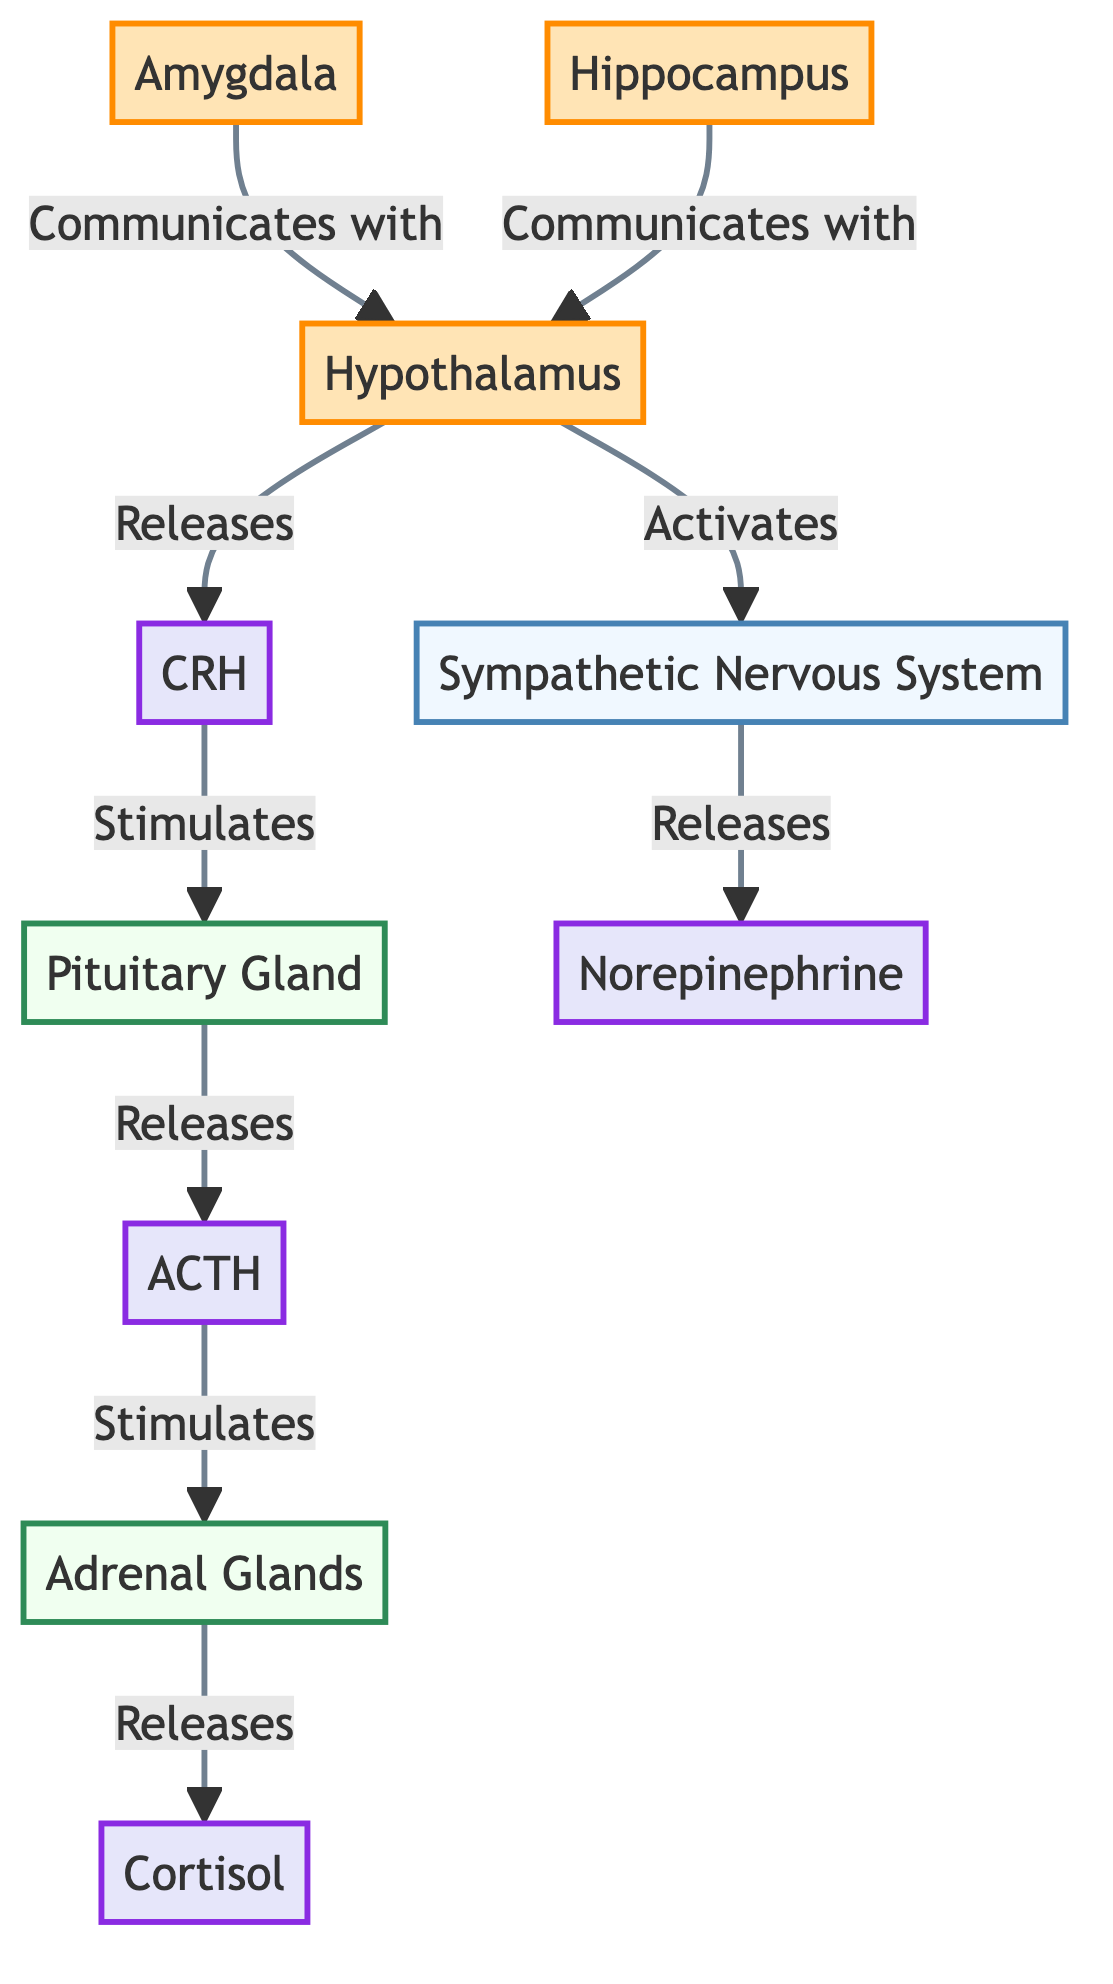What is the first gland activated in the stress response? The diagram shows that the hypothalamus releases CRH. This stimulates the pituitary gland, which then releases ACTH. However, the first gland directly involved in the stress response is the pituitary gland that is activated after the hypothalamus.
Answer: Pituitary Gland How many hormones are listed in the diagram? The diagram features four hormones: CRH, ACTH, cortisol, and norepinephrine. Counting them reveals a total of four distinct hormones.
Answer: 4 Which part of the brain communicates with the hypothalamus besides the amygdala? The diagram indicates that both the amygdala and hippocampus communicate with the hypothalamus. Therefore, answering the question involves identifying the other part mentioned, which is the hippocampus.
Answer: Hippocampus What does the sympathetic nervous system release? According to the diagram, the sympathetic nervous system is shown to release norepinephrine. This follows from the activation process that begins at the hypothalamus and progresses to the sympathetic nervous system's action.
Answer: Norepinephrine Which hormone is released by the adrenal glands? The diagram illustrates the pathway clearly, indicating that once the adrenal glands are stimulated by ACTH, they release cortisol. Therefore, the answer directly corresponds to the hormone listed in that step.
Answer: Cortisol How do CRH and ACTH interact in the stress response? The diagram reflects a sequential flow where CRH stimulates the pituitary gland which then releases ACTH. This establishes a direct relationship of causation where CRH leads to the release of ACTH from the pituitary gland.
Answer: CRH stimulates ACTH release What role does the hypothalamus play in activating the stress response? The diagram shows that the hypothalamus functions as a central node by releasing CRH and also activating the sympathetic nervous system. This indicates that the hypothalamus governs both the hormonal and nervous system responses to stress.
Answer: Central activator Which two brain structures directly communicate with the hypothalamus? From the diagram, it's observed that both the amygdala and hippocampus have direct pathways for communication with the hypothalamus. This requires recognizing two specific structures as mentioned in the flow.
Answer: Amygdala and Hippocampus What is the final outcome of the stress response represented in the diagram? The final outcome represented in the diagram can be interpreted as the release of cortisol from the adrenal glands, which is indicative of the physiological response to stress. The flow culminates in the secretion of this hormone.
Answer: Cortisol 